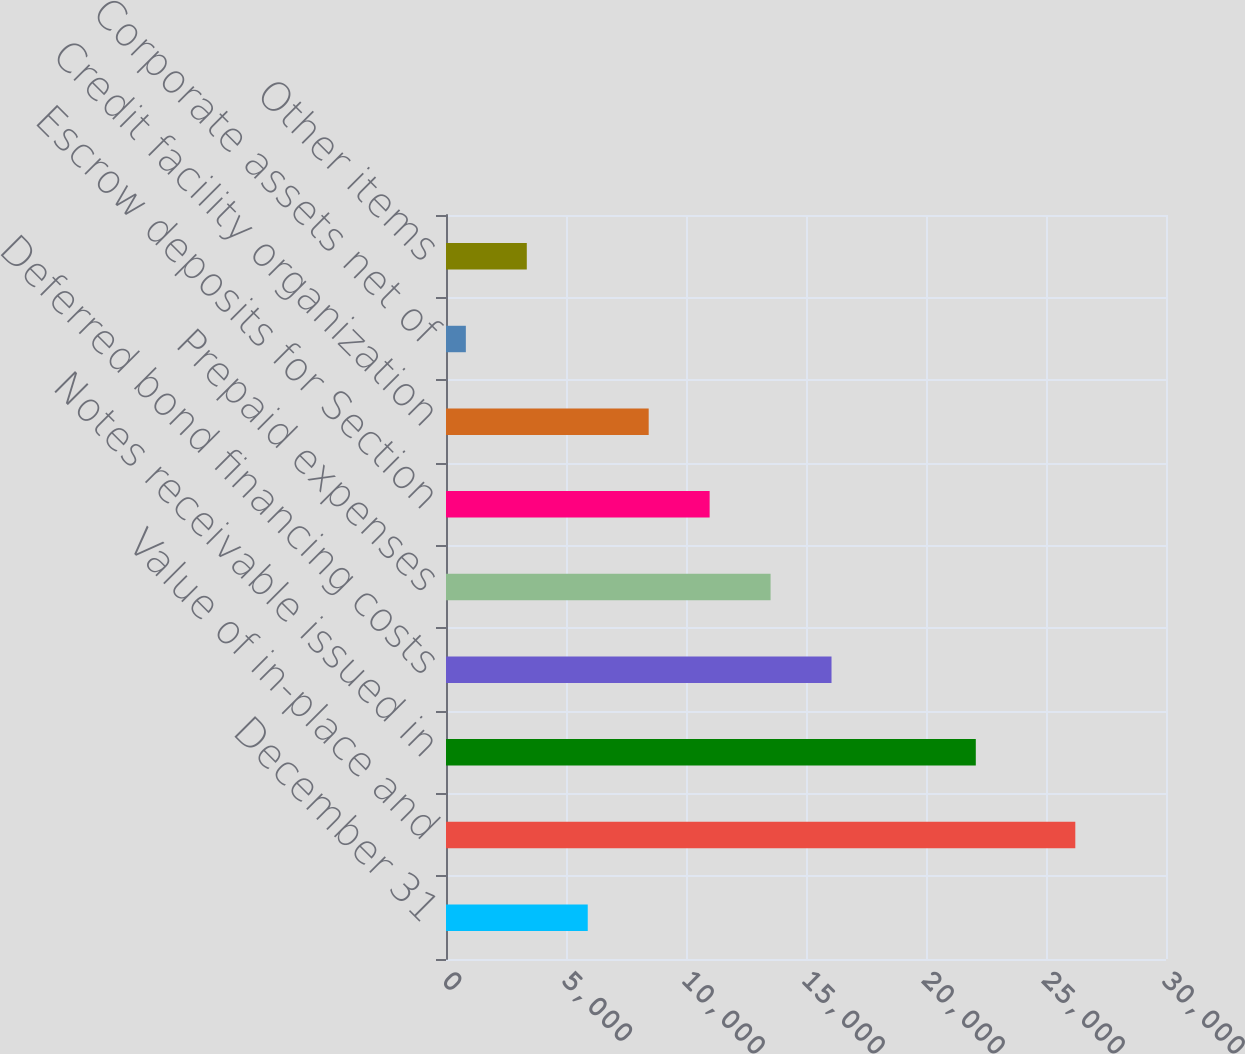Convert chart to OTSL. <chart><loc_0><loc_0><loc_500><loc_500><bar_chart><fcel>December 31<fcel>Value of in-place and<fcel>Notes receivable issued in<fcel>Deferred bond financing costs<fcel>Prepaid expenses<fcel>Escrow deposits for Section<fcel>Credit facility organization<fcel>Corporate assets net of<fcel>Other items<nl><fcel>5905.8<fcel>26221<fcel>22075<fcel>16063.4<fcel>13524<fcel>10984.6<fcel>8445.2<fcel>827<fcel>3366.4<nl></chart> 